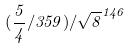<formula> <loc_0><loc_0><loc_500><loc_500>( \frac { 5 } { 4 } / 3 5 9 ) / \sqrt { 8 } ^ { 1 4 6 }</formula> 